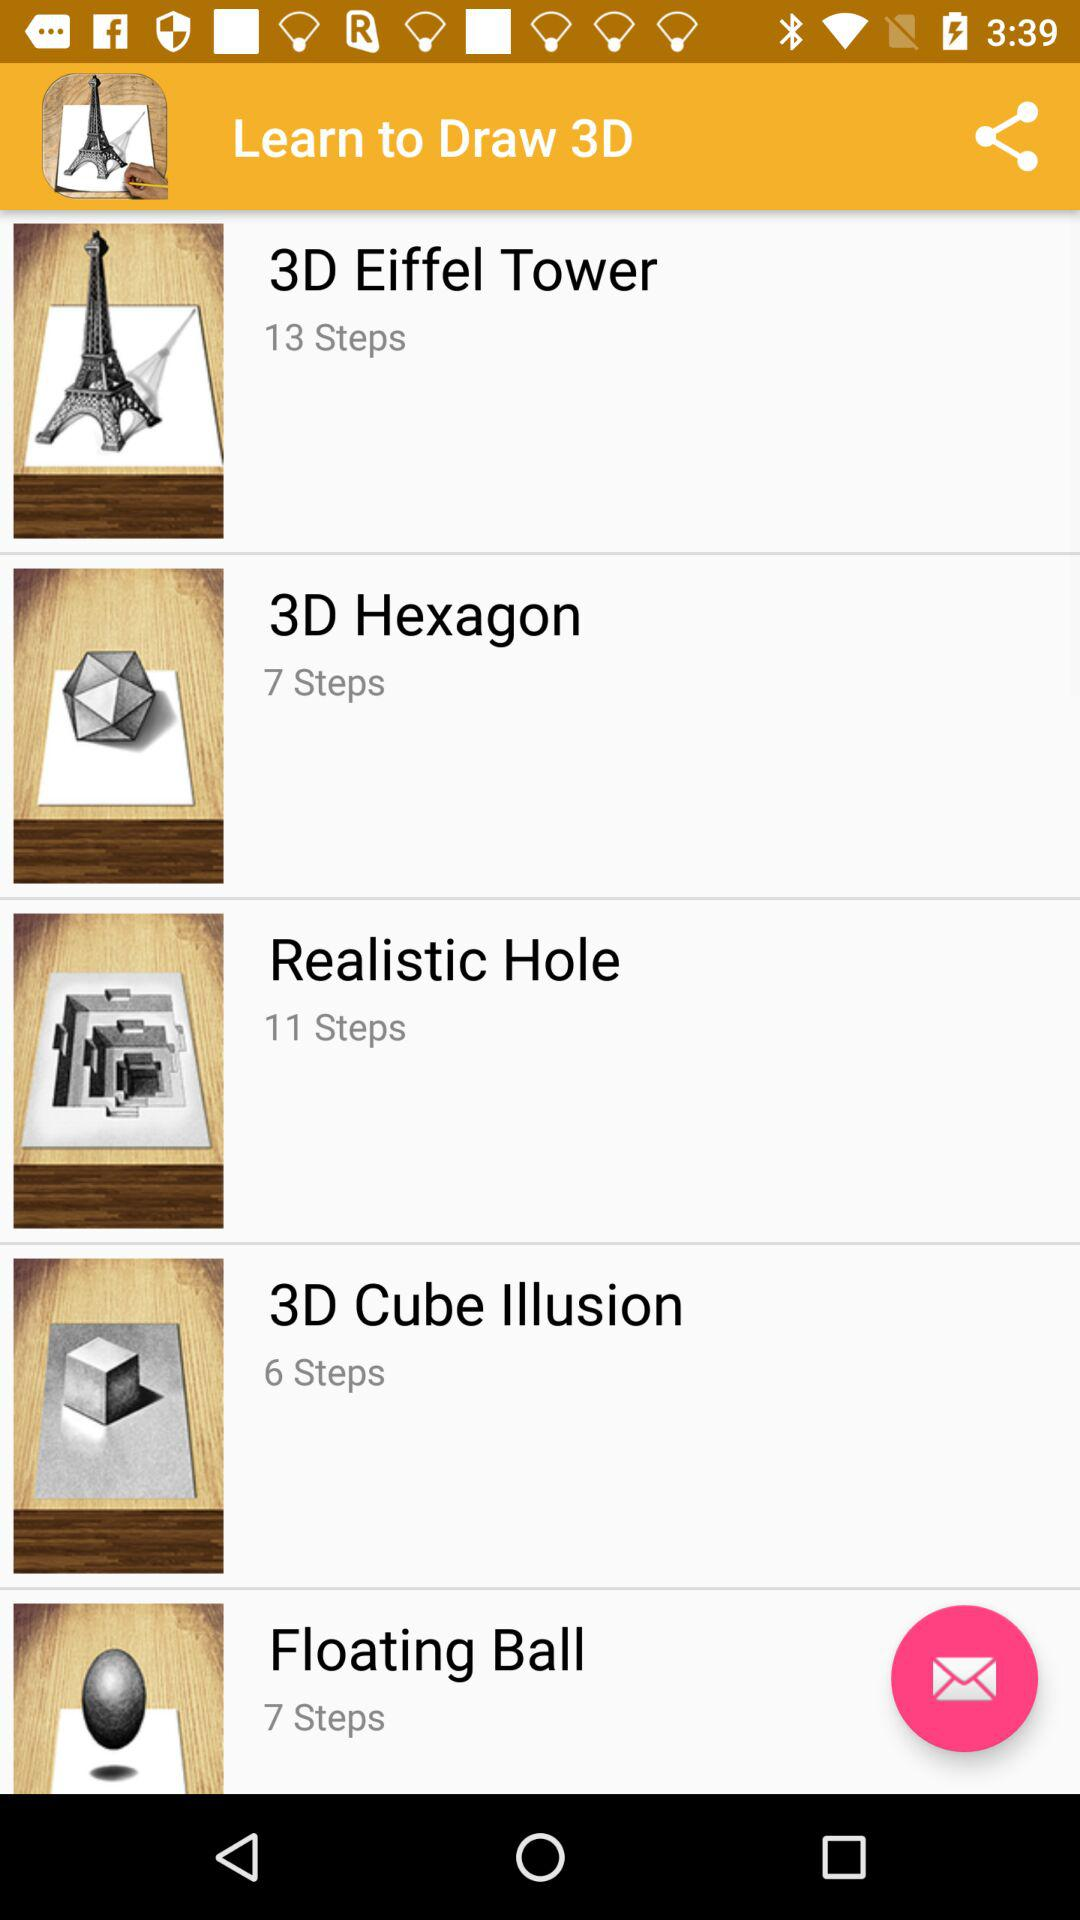What is the number of steps for drawing a 3D hexagon? The number of steps for drawing a 3D hexagon is 7. 